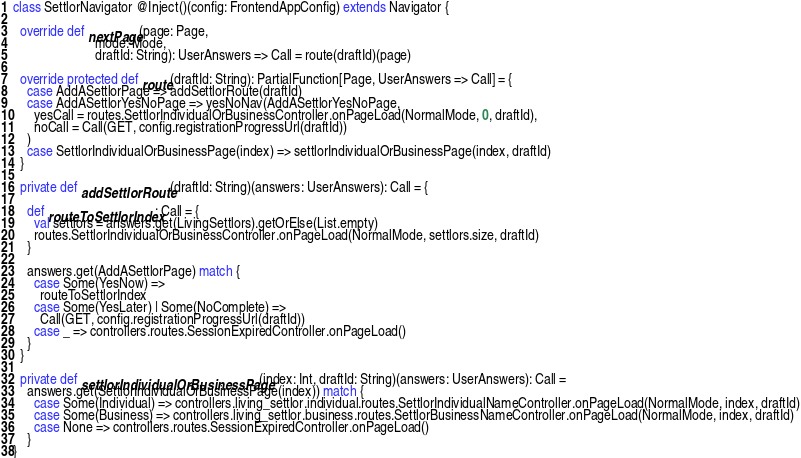<code> <loc_0><loc_0><loc_500><loc_500><_Scala_>class SettlorNavigator @Inject()(config: FrontendAppConfig) extends Navigator {

  override def nextPage(page: Page,
                        mode: Mode,
                        draftId: String): UserAnswers => Call = route(draftId)(page)

  override protected def route(draftId: String): PartialFunction[Page, UserAnswers => Call] = {
    case AddASettlorPage => addSettlorRoute(draftId)
    case AddASettlorYesNoPage => yesNoNav(AddASettlorYesNoPage,
      yesCall = routes.SettlorIndividualOrBusinessController.onPageLoad(NormalMode, 0, draftId),
      noCall = Call(GET, config.registrationProgressUrl(draftId))
    )
    case SettlorIndividualOrBusinessPage(index) => settlorIndividualOrBusinessPage(index, draftId)
  }

  private def addSettlorRoute(draftId: String)(answers: UserAnswers): Call = {

    def routeToSettlorIndex: Call = {
      val settlors = answers.get(LivingSettlors).getOrElse(List.empty)
      routes.SettlorIndividualOrBusinessController.onPageLoad(NormalMode, settlors.size, draftId)
    }

    answers.get(AddASettlorPage) match {
      case Some(YesNow) =>
        routeToSettlorIndex
      case Some(YesLater) | Some(NoComplete) =>
        Call(GET, config.registrationProgressUrl(draftId))
      case _ => controllers.routes.SessionExpiredController.onPageLoad()
    }
  }

  private def settlorIndividualOrBusinessPage(index: Int, draftId: String)(answers: UserAnswers): Call =
    answers.get(SettlorIndividualOrBusinessPage(index)) match {
      case Some(Individual) => controllers.living_settlor.individual.routes.SettlorIndividualNameController.onPageLoad(NormalMode, index, draftId)
      case Some(Business) => controllers.living_settlor.business.routes.SettlorBusinessNameController.onPageLoad(NormalMode, index, draftId)
      case None => controllers.routes.SessionExpiredController.onPageLoad()
    }
}
</code> 